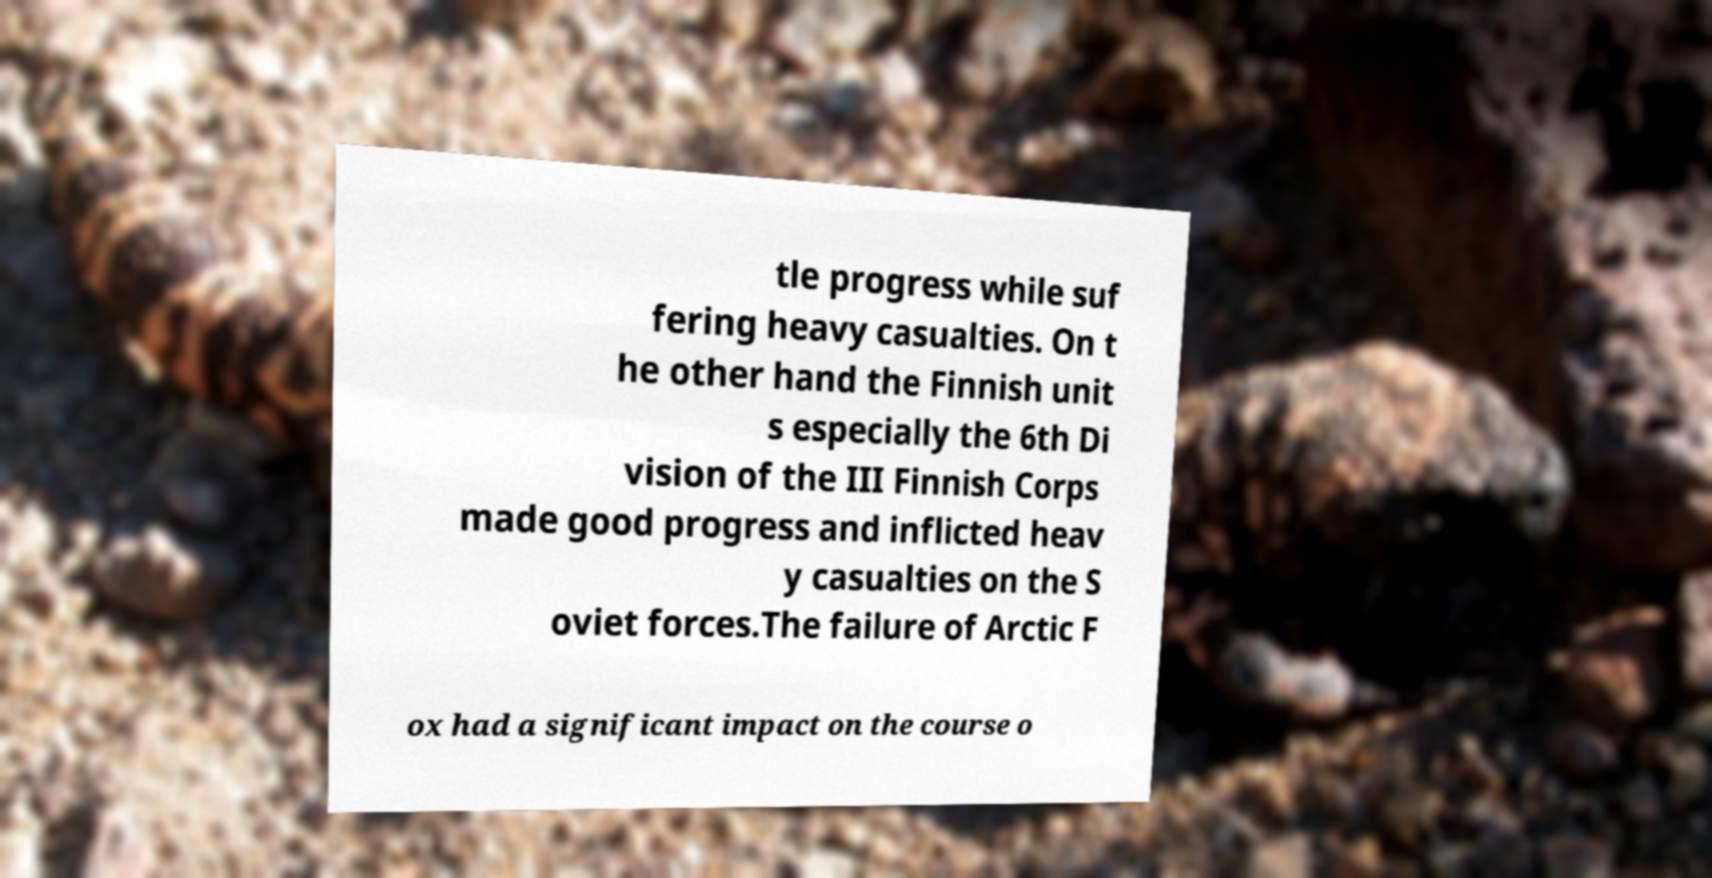Can you accurately transcribe the text from the provided image for me? tle progress while suf fering heavy casualties. On t he other hand the Finnish unit s especially the 6th Di vision of the III Finnish Corps made good progress and inflicted heav y casualties on the S oviet forces.The failure of Arctic F ox had a significant impact on the course o 